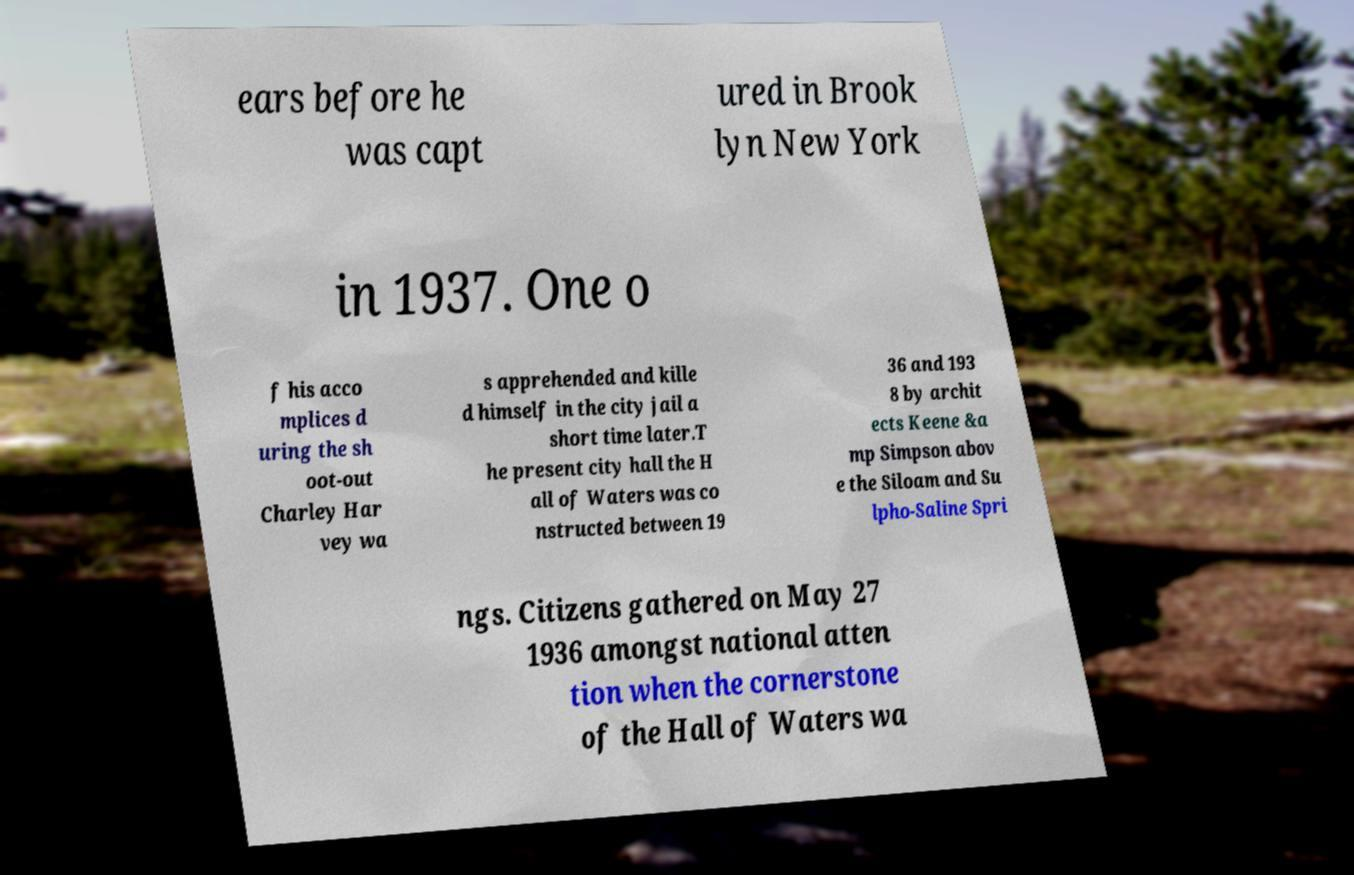I need the written content from this picture converted into text. Can you do that? ears before he was capt ured in Brook lyn New York in 1937. One o f his acco mplices d uring the sh oot-out Charley Har vey wa s apprehended and kille d himself in the city jail a short time later.T he present city hall the H all of Waters was co nstructed between 19 36 and 193 8 by archit ects Keene &a mp Simpson abov e the Siloam and Su lpho-Saline Spri ngs. Citizens gathered on May 27 1936 amongst national atten tion when the cornerstone of the Hall of Waters wa 